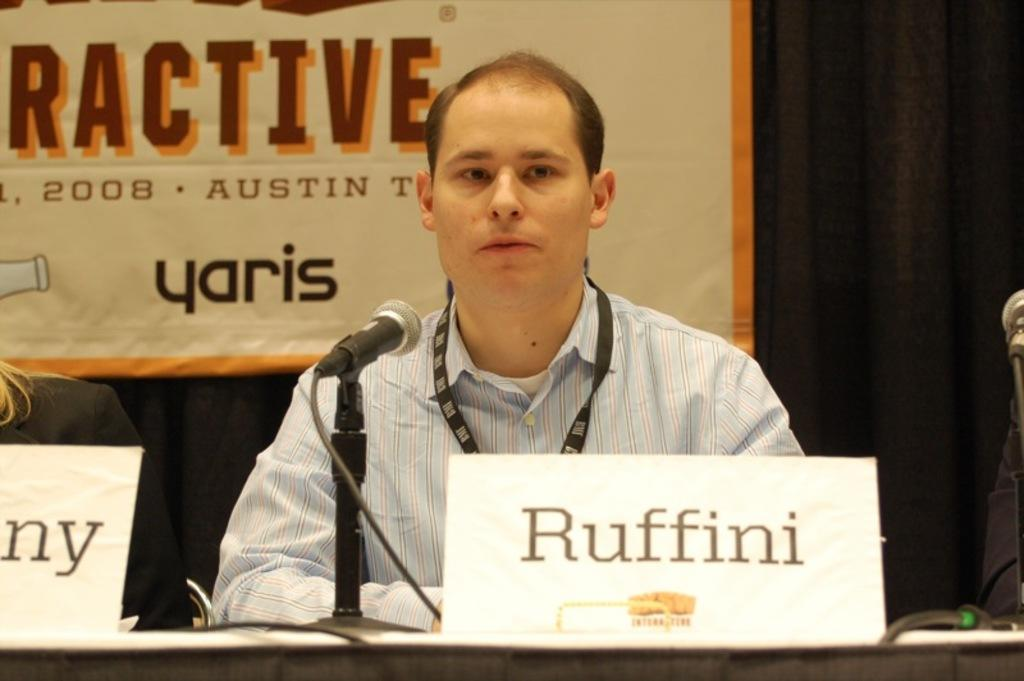What are the persons in the image doing? The persons in the image are sitting. What is on the table in the image? There is a table in the image with boards and a microphone on it. What is at the back of the image? There is a curtain at the back of the image with a banner attached to it. Can you see the father of the persons sitting in the image? There is no information about the father of the persons sitting in the image, so it cannot be determined from the image. Is there a cat visible in the image? There is no cat present in the image. 